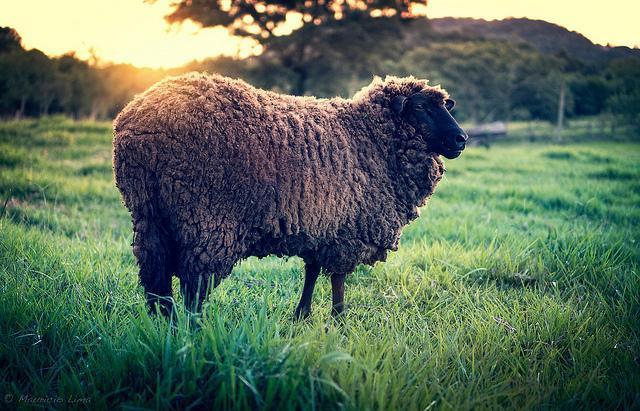How many airplanes are in front of the control towers?
Give a very brief answer. 0. 